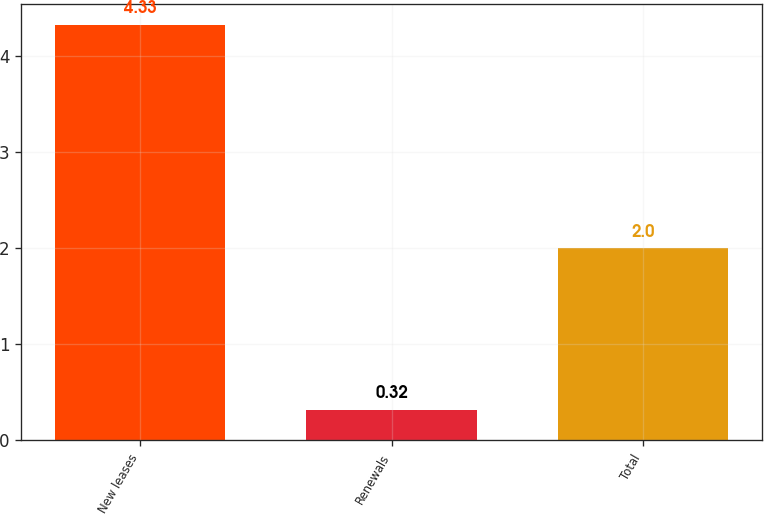<chart> <loc_0><loc_0><loc_500><loc_500><bar_chart><fcel>New leases<fcel>Renewals<fcel>Total<nl><fcel>4.33<fcel>0.32<fcel>2<nl></chart> 